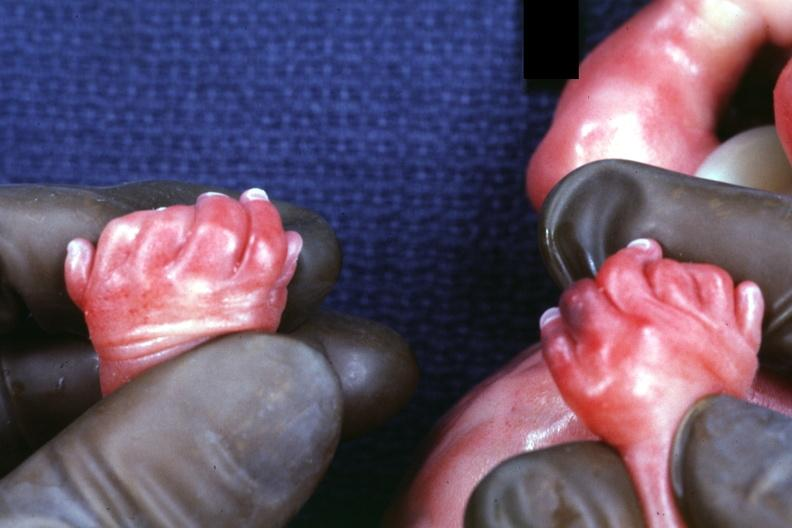s focal hemorrhagic infarction well shown present?
Answer the question using a single word or phrase. No 